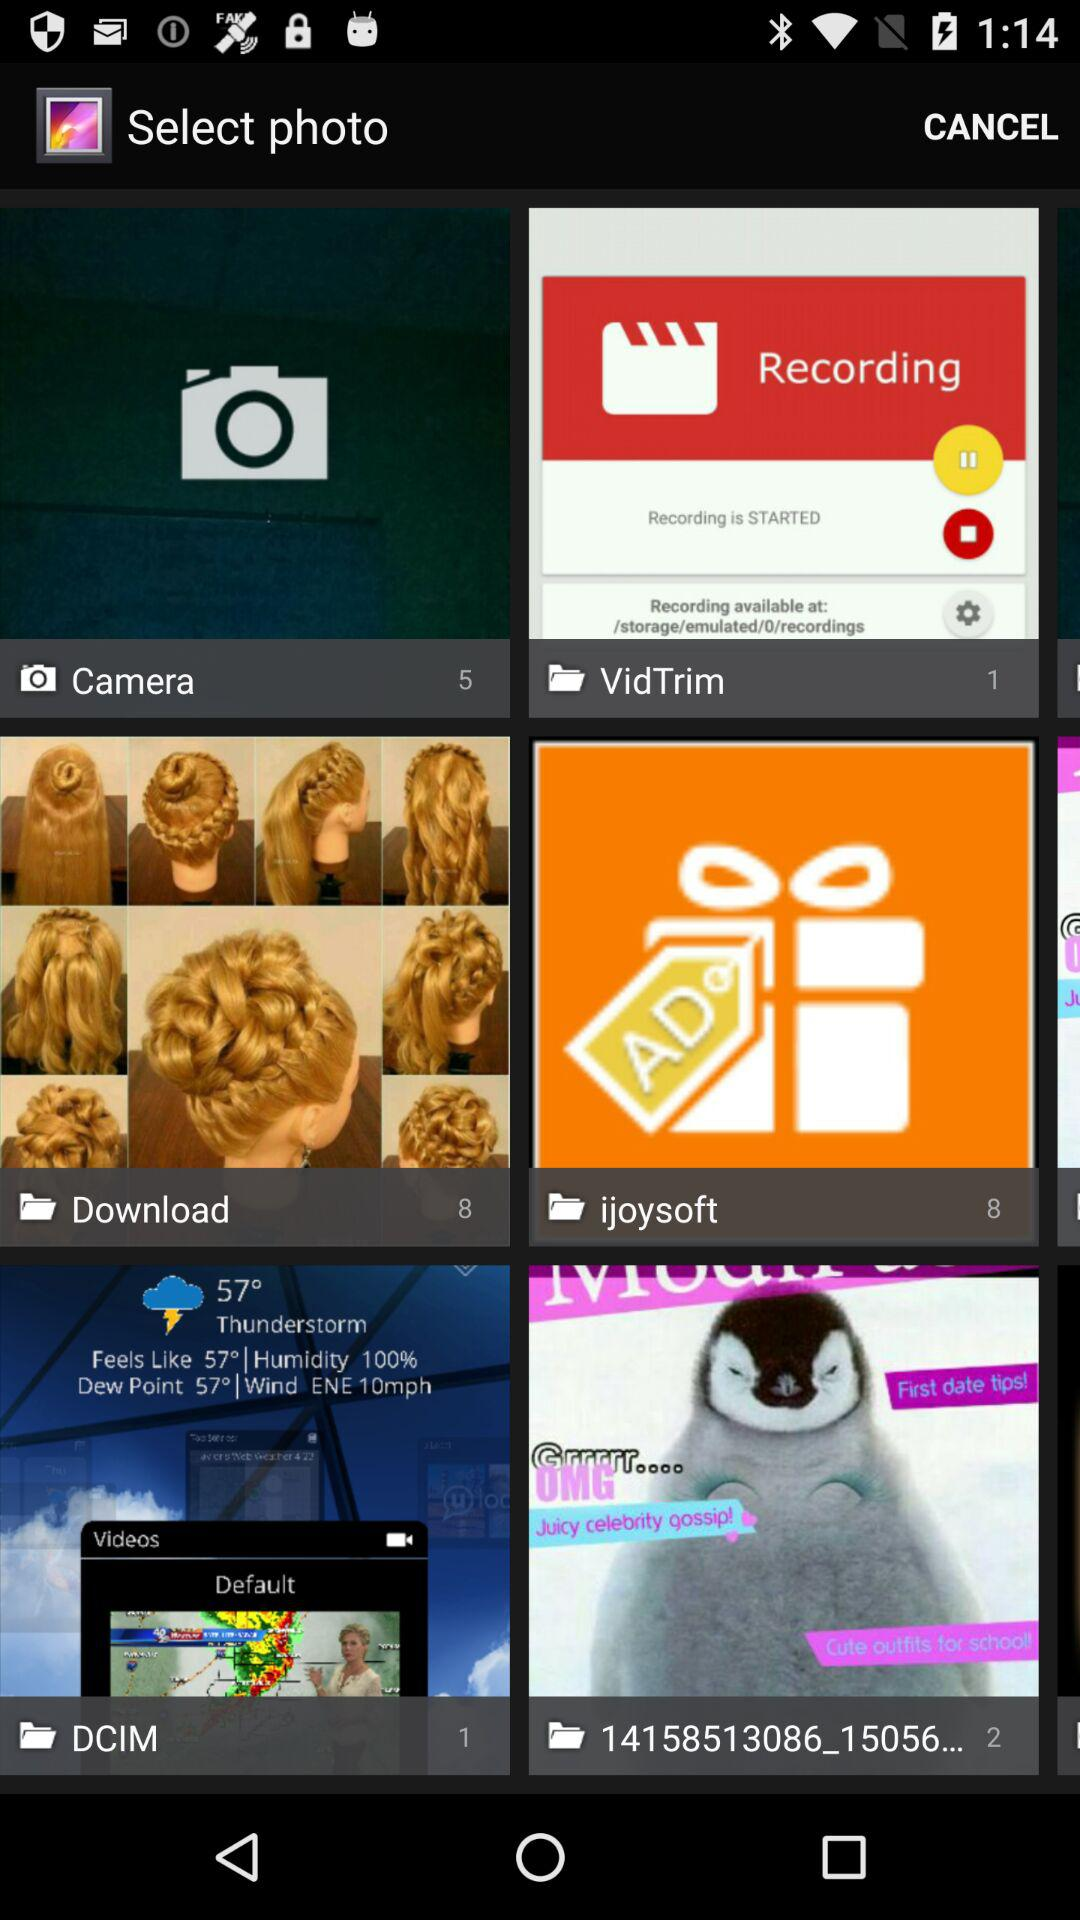How many photos are there in "Download" folder? There are 8 photos. 